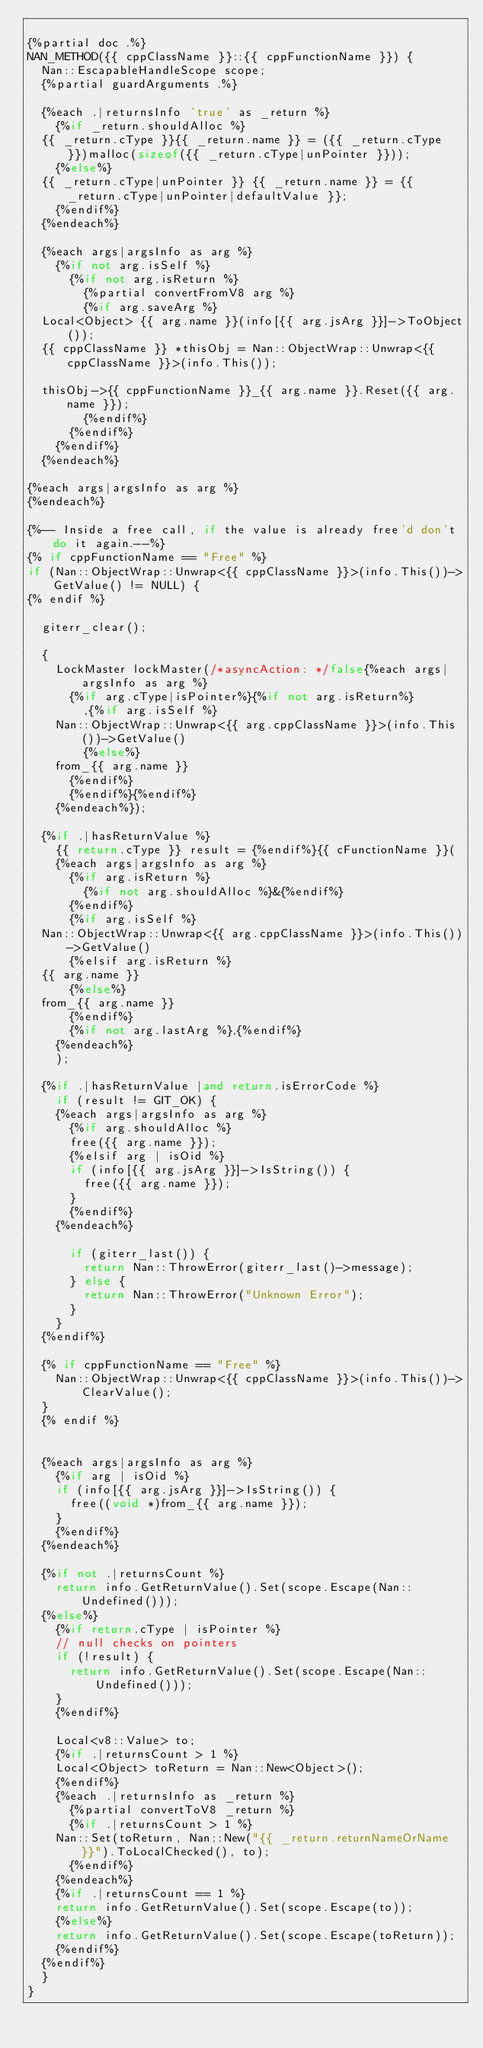Convert code to text. <code><loc_0><loc_0><loc_500><loc_500><_C++_>
{%partial doc .%}
NAN_METHOD({{ cppClassName }}::{{ cppFunctionName }}) {
  Nan::EscapableHandleScope scope;
  {%partial guardArguments .%}

  {%each .|returnsInfo 'true' as _return %}
    {%if _return.shouldAlloc %}
  {{ _return.cType }}{{ _return.name }} = ({{ _return.cType }})malloc(sizeof({{ _return.cType|unPointer }}));
    {%else%}
  {{ _return.cType|unPointer }} {{ _return.name }} = {{ _return.cType|unPointer|defaultValue }};
    {%endif%}
  {%endeach%}

  {%each args|argsInfo as arg %}
    {%if not arg.isSelf %}
      {%if not arg.isReturn %}
        {%partial convertFromV8 arg %}
        {%if arg.saveArg %}
  Local<Object> {{ arg.name }}(info[{{ arg.jsArg }}]->ToObject());
  {{ cppClassName }} *thisObj = Nan::ObjectWrap::Unwrap<{{ cppClassName }}>(info.This());

  thisObj->{{ cppFunctionName }}_{{ arg.name }}.Reset({{ arg.name }});
        {%endif%}
      {%endif%}
    {%endif%}
  {%endeach%}

{%each args|argsInfo as arg %}
{%endeach%}

{%-- Inside a free call, if the value is already free'd don't do it again.--%}
{% if cppFunctionName == "Free" %}
if (Nan::ObjectWrap::Unwrap<{{ cppClassName }}>(info.This())->GetValue() != NULL) {
{% endif %}

  giterr_clear();

  {
    LockMaster lockMaster(/*asyncAction: */false{%each args|argsInfo as arg %}
      {%if arg.cType|isPointer%}{%if not arg.isReturn%}
        ,{%if arg.isSelf %}
    Nan::ObjectWrap::Unwrap<{{ arg.cppClassName }}>(info.This())->GetValue()
        {%else%}
    from_{{ arg.name }}
      {%endif%}
      {%endif%}{%endif%}
    {%endeach%});

  {%if .|hasReturnValue %}
    {{ return.cType }} result = {%endif%}{{ cFunctionName }}(
    {%each args|argsInfo as arg %}
      {%if arg.isReturn %}
        {%if not arg.shouldAlloc %}&{%endif%}
      {%endif%}
      {%if arg.isSelf %}
  Nan::ObjectWrap::Unwrap<{{ arg.cppClassName }}>(info.This())->GetValue()
      {%elsif arg.isReturn %}
  {{ arg.name }}
      {%else%}
  from_{{ arg.name }}
      {%endif%}
      {%if not arg.lastArg %},{%endif%}
    {%endeach%}
    );

  {%if .|hasReturnValue |and return.isErrorCode %}
    if (result != GIT_OK) {
    {%each args|argsInfo as arg %}
      {%if arg.shouldAlloc %}
      free({{ arg.name }});
      {%elsif arg | isOid %}
      if (info[{{ arg.jsArg }}]->IsString()) {
        free({{ arg.name }});
      }
      {%endif%}
    {%endeach%}

      if (giterr_last()) {
        return Nan::ThrowError(giterr_last()->message);
      } else {
        return Nan::ThrowError("Unknown Error");
      }
    }
  {%endif%}

  {% if cppFunctionName == "Free" %}
    Nan::ObjectWrap::Unwrap<{{ cppClassName }}>(info.This())->ClearValue();
  }
  {% endif %}


  {%each args|argsInfo as arg %}
    {%if arg | isOid %}
    if (info[{{ arg.jsArg }}]->IsString()) {
      free((void *)from_{{ arg.name }});
    }
    {%endif%}
  {%endeach%}

  {%if not .|returnsCount %}
    return info.GetReturnValue().Set(scope.Escape(Nan::Undefined()));
  {%else%}
    {%if return.cType | isPointer %}
    // null checks on pointers
    if (!result) {
      return info.GetReturnValue().Set(scope.Escape(Nan::Undefined()));
    }
    {%endif%}

    Local<v8::Value> to;
    {%if .|returnsCount > 1 %}
    Local<Object> toReturn = Nan::New<Object>();
    {%endif%}
    {%each .|returnsInfo as _return %}
      {%partial convertToV8 _return %}
      {%if .|returnsCount > 1 %}
    Nan::Set(toReturn, Nan::New("{{ _return.returnNameOrName }}").ToLocalChecked(), to);
      {%endif%}
    {%endeach%}
    {%if .|returnsCount == 1 %}
    return info.GetReturnValue().Set(scope.Escape(to));
    {%else%}
    return info.GetReturnValue().Set(scope.Escape(toReturn));
    {%endif%}
  {%endif%}
  }
}
</code> 